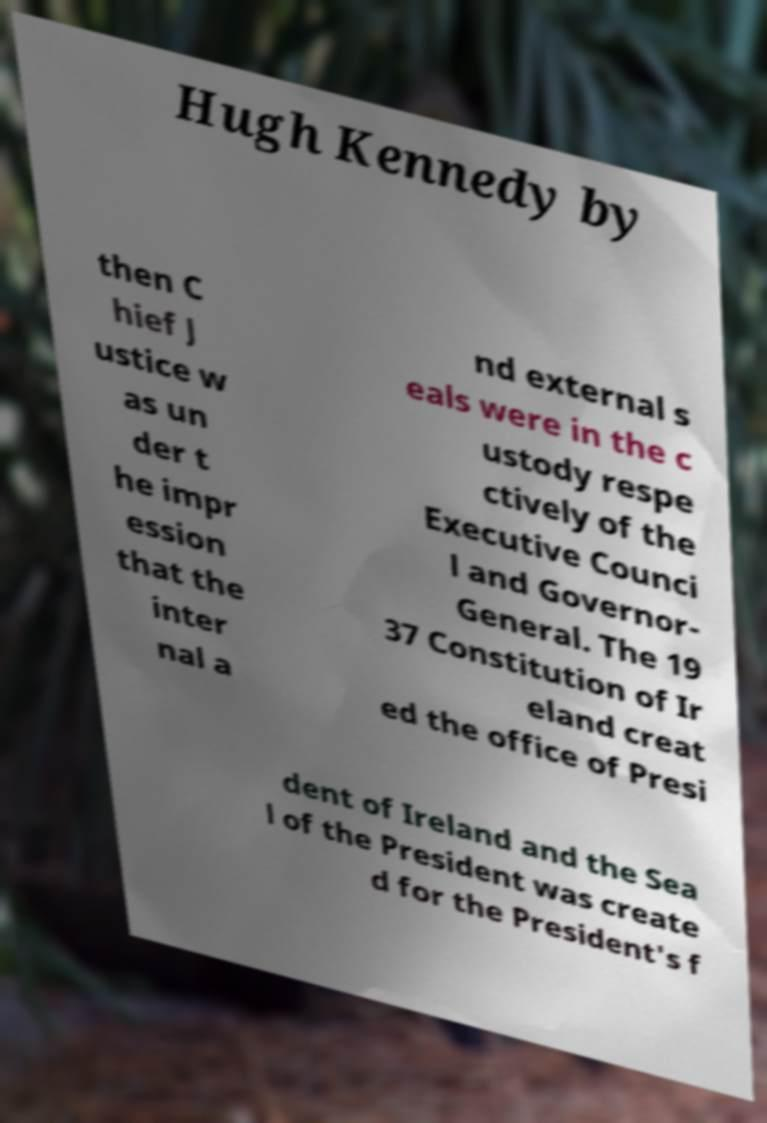What messages or text are displayed in this image? I need them in a readable, typed format. Hugh Kennedy by then C hief J ustice w as un der t he impr ession that the inter nal a nd external s eals were in the c ustody respe ctively of the Executive Counci l and Governor- General. The 19 37 Constitution of Ir eland creat ed the office of Presi dent of Ireland and the Sea l of the President was create d for the President's f 